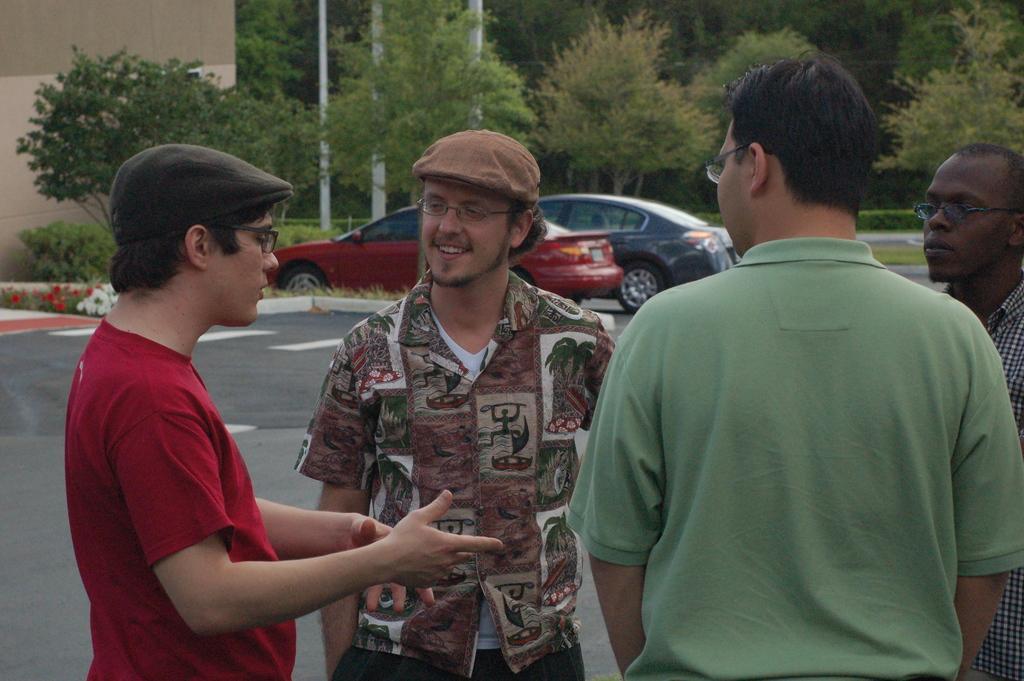Could you give a brief overview of what you see in this image? As we can see in the image in the front there are few people standing. In the background there is a house, poles, trees, grass and cars. 